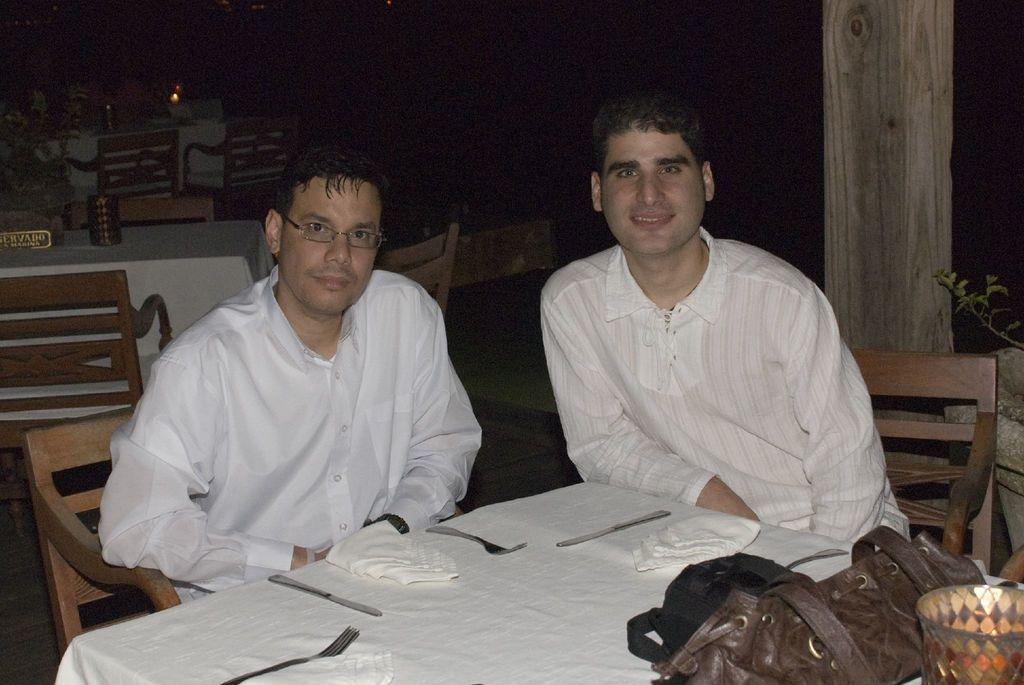How many people are in the image? There are two men in the image. What are the men doing in the image? The men are sitting on chairs. What are the men wearing in the image? The men are wearing white shirts. What piece of furniture is present in the image? There is a dining table in the image. What utensils can be seen on the dining table? Knives and forks are on the dining table. What is the aftermath of the fold in the image? There is no fold or aftermath mentioned in the image; it features two men sitting on chairs and wearing white shirts. 